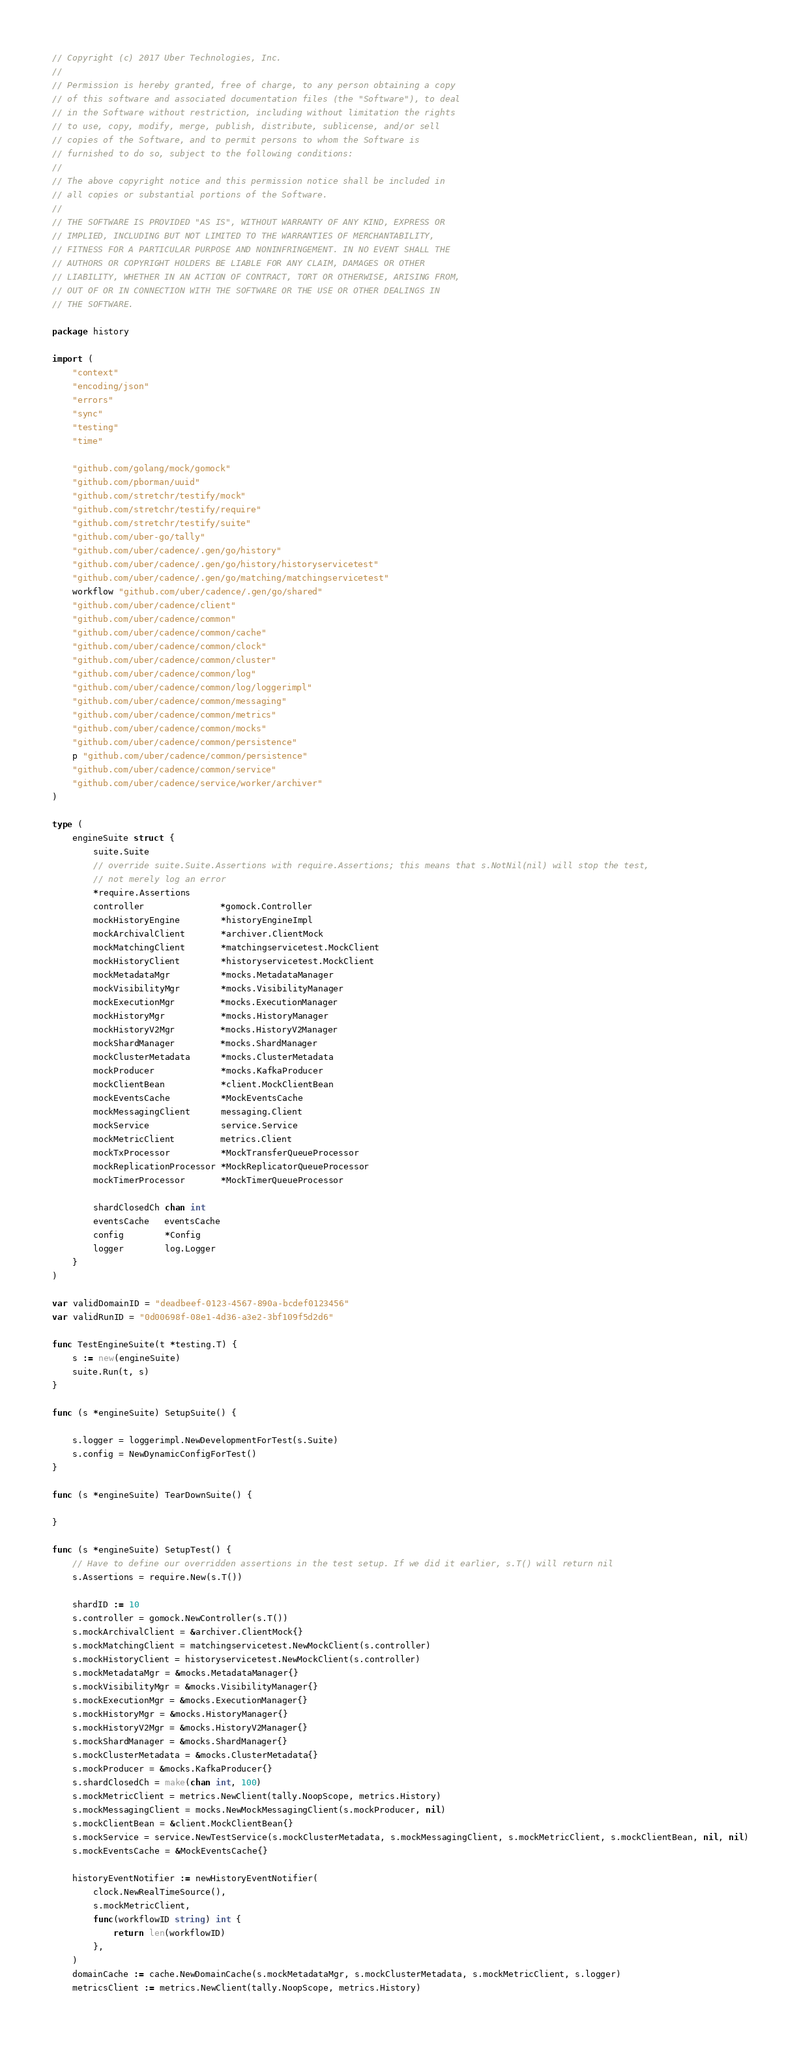Convert code to text. <code><loc_0><loc_0><loc_500><loc_500><_Go_>// Copyright (c) 2017 Uber Technologies, Inc.
//
// Permission is hereby granted, free of charge, to any person obtaining a copy
// of this software and associated documentation files (the "Software"), to deal
// in the Software without restriction, including without limitation the rights
// to use, copy, modify, merge, publish, distribute, sublicense, and/or sell
// copies of the Software, and to permit persons to whom the Software is
// furnished to do so, subject to the following conditions:
//
// The above copyright notice and this permission notice shall be included in
// all copies or substantial portions of the Software.
//
// THE SOFTWARE IS PROVIDED "AS IS", WITHOUT WARRANTY OF ANY KIND, EXPRESS OR
// IMPLIED, INCLUDING BUT NOT LIMITED TO THE WARRANTIES OF MERCHANTABILITY,
// FITNESS FOR A PARTICULAR PURPOSE AND NONINFRINGEMENT. IN NO EVENT SHALL THE
// AUTHORS OR COPYRIGHT HOLDERS BE LIABLE FOR ANY CLAIM, DAMAGES OR OTHER
// LIABILITY, WHETHER IN AN ACTION OF CONTRACT, TORT OR OTHERWISE, ARISING FROM,
// OUT OF OR IN CONNECTION WITH THE SOFTWARE OR THE USE OR OTHER DEALINGS IN
// THE SOFTWARE.

package history

import (
	"context"
	"encoding/json"
	"errors"
	"sync"
	"testing"
	"time"

	"github.com/golang/mock/gomock"
	"github.com/pborman/uuid"
	"github.com/stretchr/testify/mock"
	"github.com/stretchr/testify/require"
	"github.com/stretchr/testify/suite"
	"github.com/uber-go/tally"
	"github.com/uber/cadence/.gen/go/history"
	"github.com/uber/cadence/.gen/go/history/historyservicetest"
	"github.com/uber/cadence/.gen/go/matching/matchingservicetest"
	workflow "github.com/uber/cadence/.gen/go/shared"
	"github.com/uber/cadence/client"
	"github.com/uber/cadence/common"
	"github.com/uber/cadence/common/cache"
	"github.com/uber/cadence/common/clock"
	"github.com/uber/cadence/common/cluster"
	"github.com/uber/cadence/common/log"
	"github.com/uber/cadence/common/log/loggerimpl"
	"github.com/uber/cadence/common/messaging"
	"github.com/uber/cadence/common/metrics"
	"github.com/uber/cadence/common/mocks"
	"github.com/uber/cadence/common/persistence"
	p "github.com/uber/cadence/common/persistence"
	"github.com/uber/cadence/common/service"
	"github.com/uber/cadence/service/worker/archiver"
)

type (
	engineSuite struct {
		suite.Suite
		// override suite.Suite.Assertions with require.Assertions; this means that s.NotNil(nil) will stop the test,
		// not merely log an error
		*require.Assertions
		controller               *gomock.Controller
		mockHistoryEngine        *historyEngineImpl
		mockArchivalClient       *archiver.ClientMock
		mockMatchingClient       *matchingservicetest.MockClient
		mockHistoryClient        *historyservicetest.MockClient
		mockMetadataMgr          *mocks.MetadataManager
		mockVisibilityMgr        *mocks.VisibilityManager
		mockExecutionMgr         *mocks.ExecutionManager
		mockHistoryMgr           *mocks.HistoryManager
		mockHistoryV2Mgr         *mocks.HistoryV2Manager
		mockShardManager         *mocks.ShardManager
		mockClusterMetadata      *mocks.ClusterMetadata
		mockProducer             *mocks.KafkaProducer
		mockClientBean           *client.MockClientBean
		mockEventsCache          *MockEventsCache
		mockMessagingClient      messaging.Client
		mockService              service.Service
		mockMetricClient         metrics.Client
		mockTxProcessor          *MockTransferQueueProcessor
		mockReplicationProcessor *MockReplicatorQueueProcessor
		mockTimerProcessor       *MockTimerQueueProcessor

		shardClosedCh chan int
		eventsCache   eventsCache
		config        *Config
		logger        log.Logger
	}
)

var validDomainID = "deadbeef-0123-4567-890a-bcdef0123456"
var validRunID = "0d00698f-08e1-4d36-a3e2-3bf109f5d2d6"

func TestEngineSuite(t *testing.T) {
	s := new(engineSuite)
	suite.Run(t, s)
}

func (s *engineSuite) SetupSuite() {

	s.logger = loggerimpl.NewDevelopmentForTest(s.Suite)
	s.config = NewDynamicConfigForTest()
}

func (s *engineSuite) TearDownSuite() {

}

func (s *engineSuite) SetupTest() {
	// Have to define our overridden assertions in the test setup. If we did it earlier, s.T() will return nil
	s.Assertions = require.New(s.T())

	shardID := 10
	s.controller = gomock.NewController(s.T())
	s.mockArchivalClient = &archiver.ClientMock{}
	s.mockMatchingClient = matchingservicetest.NewMockClient(s.controller)
	s.mockHistoryClient = historyservicetest.NewMockClient(s.controller)
	s.mockMetadataMgr = &mocks.MetadataManager{}
	s.mockVisibilityMgr = &mocks.VisibilityManager{}
	s.mockExecutionMgr = &mocks.ExecutionManager{}
	s.mockHistoryMgr = &mocks.HistoryManager{}
	s.mockHistoryV2Mgr = &mocks.HistoryV2Manager{}
	s.mockShardManager = &mocks.ShardManager{}
	s.mockClusterMetadata = &mocks.ClusterMetadata{}
	s.mockProducer = &mocks.KafkaProducer{}
	s.shardClosedCh = make(chan int, 100)
	s.mockMetricClient = metrics.NewClient(tally.NoopScope, metrics.History)
	s.mockMessagingClient = mocks.NewMockMessagingClient(s.mockProducer, nil)
	s.mockClientBean = &client.MockClientBean{}
	s.mockService = service.NewTestService(s.mockClusterMetadata, s.mockMessagingClient, s.mockMetricClient, s.mockClientBean, nil, nil)
	s.mockEventsCache = &MockEventsCache{}

	historyEventNotifier := newHistoryEventNotifier(
		clock.NewRealTimeSource(),
		s.mockMetricClient,
		func(workflowID string) int {
			return len(workflowID)
		},
	)
	domainCache := cache.NewDomainCache(s.mockMetadataMgr, s.mockClusterMetadata, s.mockMetricClient, s.logger)
	metricsClient := metrics.NewClient(tally.NoopScope, metrics.History)</code> 